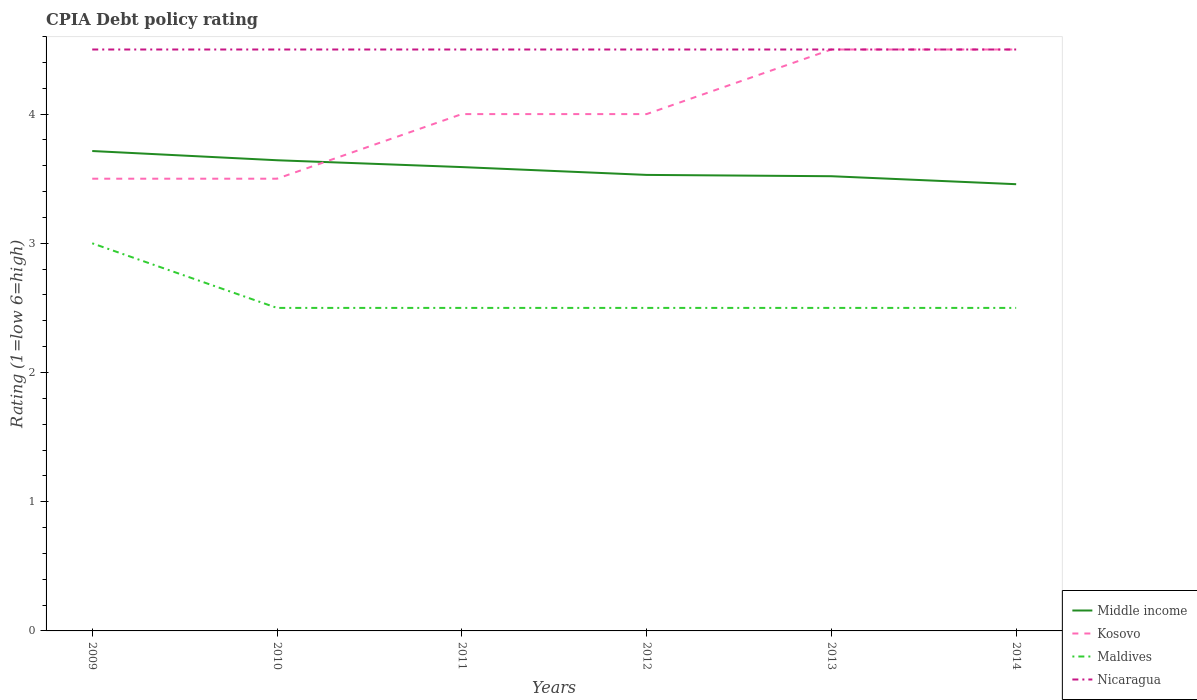How many different coloured lines are there?
Your response must be concise. 4. Does the line corresponding to Kosovo intersect with the line corresponding to Nicaragua?
Provide a short and direct response. Yes. Is the number of lines equal to the number of legend labels?
Ensure brevity in your answer.  Yes. Across all years, what is the maximum CPIA rating in Maldives?
Your answer should be compact. 2.5. What is the total CPIA rating in Maldives in the graph?
Provide a short and direct response. 0. Is the CPIA rating in Maldives strictly greater than the CPIA rating in Kosovo over the years?
Give a very brief answer. Yes. How many lines are there?
Your answer should be compact. 4. How many years are there in the graph?
Your answer should be compact. 6. What is the difference between two consecutive major ticks on the Y-axis?
Your response must be concise. 1. Are the values on the major ticks of Y-axis written in scientific E-notation?
Make the answer very short. No. Does the graph contain any zero values?
Provide a short and direct response. No. Does the graph contain grids?
Ensure brevity in your answer.  No. What is the title of the graph?
Keep it short and to the point. CPIA Debt policy rating. What is the label or title of the X-axis?
Offer a very short reply. Years. What is the label or title of the Y-axis?
Your answer should be compact. Rating (1=low 6=high). What is the Rating (1=low 6=high) of Middle income in 2009?
Offer a terse response. 3.71. What is the Rating (1=low 6=high) in Middle income in 2010?
Offer a very short reply. 3.64. What is the Rating (1=low 6=high) of Kosovo in 2010?
Keep it short and to the point. 3.5. What is the Rating (1=low 6=high) of Nicaragua in 2010?
Provide a succinct answer. 4.5. What is the Rating (1=low 6=high) of Middle income in 2011?
Provide a succinct answer. 3.59. What is the Rating (1=low 6=high) of Kosovo in 2011?
Your response must be concise. 4. What is the Rating (1=low 6=high) of Maldives in 2011?
Keep it short and to the point. 2.5. What is the Rating (1=low 6=high) of Nicaragua in 2011?
Offer a terse response. 4.5. What is the Rating (1=low 6=high) in Middle income in 2012?
Give a very brief answer. 3.53. What is the Rating (1=low 6=high) of Maldives in 2012?
Your response must be concise. 2.5. What is the Rating (1=low 6=high) in Nicaragua in 2012?
Provide a short and direct response. 4.5. What is the Rating (1=low 6=high) of Middle income in 2013?
Your response must be concise. 3.52. What is the Rating (1=low 6=high) in Kosovo in 2013?
Provide a succinct answer. 4.5. What is the Rating (1=low 6=high) in Nicaragua in 2013?
Provide a succinct answer. 4.5. What is the Rating (1=low 6=high) in Middle income in 2014?
Your answer should be compact. 3.46. What is the Rating (1=low 6=high) of Kosovo in 2014?
Your answer should be compact. 4.5. What is the Rating (1=low 6=high) in Nicaragua in 2014?
Make the answer very short. 4.5. Across all years, what is the maximum Rating (1=low 6=high) of Middle income?
Your response must be concise. 3.71. Across all years, what is the minimum Rating (1=low 6=high) in Middle income?
Give a very brief answer. 3.46. Across all years, what is the minimum Rating (1=low 6=high) of Maldives?
Offer a very short reply. 2.5. What is the total Rating (1=low 6=high) of Middle income in the graph?
Your answer should be very brief. 21.45. What is the total Rating (1=low 6=high) in Kosovo in the graph?
Your answer should be compact. 24. What is the difference between the Rating (1=low 6=high) of Middle income in 2009 and that in 2010?
Provide a short and direct response. 0.07. What is the difference between the Rating (1=low 6=high) of Kosovo in 2009 and that in 2010?
Make the answer very short. 0. What is the difference between the Rating (1=low 6=high) in Maldives in 2009 and that in 2010?
Offer a very short reply. 0.5. What is the difference between the Rating (1=low 6=high) of Middle income in 2009 and that in 2011?
Offer a terse response. 0.12. What is the difference between the Rating (1=low 6=high) in Nicaragua in 2009 and that in 2011?
Offer a terse response. 0. What is the difference between the Rating (1=low 6=high) in Middle income in 2009 and that in 2012?
Keep it short and to the point. 0.18. What is the difference between the Rating (1=low 6=high) in Middle income in 2009 and that in 2013?
Your answer should be compact. 0.2. What is the difference between the Rating (1=low 6=high) in Kosovo in 2009 and that in 2013?
Offer a terse response. -1. What is the difference between the Rating (1=low 6=high) in Maldives in 2009 and that in 2013?
Offer a very short reply. 0.5. What is the difference between the Rating (1=low 6=high) in Nicaragua in 2009 and that in 2013?
Make the answer very short. 0. What is the difference between the Rating (1=low 6=high) of Middle income in 2009 and that in 2014?
Ensure brevity in your answer.  0.26. What is the difference between the Rating (1=low 6=high) in Kosovo in 2009 and that in 2014?
Offer a terse response. -1. What is the difference between the Rating (1=low 6=high) in Middle income in 2010 and that in 2011?
Make the answer very short. 0.05. What is the difference between the Rating (1=low 6=high) of Kosovo in 2010 and that in 2011?
Your answer should be very brief. -0.5. What is the difference between the Rating (1=low 6=high) in Maldives in 2010 and that in 2011?
Give a very brief answer. 0. What is the difference between the Rating (1=low 6=high) of Middle income in 2010 and that in 2012?
Your response must be concise. 0.11. What is the difference between the Rating (1=low 6=high) in Nicaragua in 2010 and that in 2012?
Keep it short and to the point. 0. What is the difference between the Rating (1=low 6=high) of Middle income in 2010 and that in 2013?
Offer a terse response. 0.12. What is the difference between the Rating (1=low 6=high) in Kosovo in 2010 and that in 2013?
Ensure brevity in your answer.  -1. What is the difference between the Rating (1=low 6=high) in Maldives in 2010 and that in 2013?
Make the answer very short. 0. What is the difference between the Rating (1=low 6=high) of Middle income in 2010 and that in 2014?
Your response must be concise. 0.19. What is the difference between the Rating (1=low 6=high) in Middle income in 2011 and that in 2012?
Provide a succinct answer. 0.06. What is the difference between the Rating (1=low 6=high) of Kosovo in 2011 and that in 2012?
Your response must be concise. 0. What is the difference between the Rating (1=low 6=high) in Middle income in 2011 and that in 2013?
Keep it short and to the point. 0.07. What is the difference between the Rating (1=low 6=high) of Kosovo in 2011 and that in 2013?
Ensure brevity in your answer.  -0.5. What is the difference between the Rating (1=low 6=high) in Middle income in 2011 and that in 2014?
Provide a succinct answer. 0.13. What is the difference between the Rating (1=low 6=high) in Nicaragua in 2011 and that in 2014?
Your response must be concise. 0. What is the difference between the Rating (1=low 6=high) in Middle income in 2012 and that in 2013?
Your answer should be very brief. 0.01. What is the difference between the Rating (1=low 6=high) of Kosovo in 2012 and that in 2013?
Your answer should be compact. -0.5. What is the difference between the Rating (1=low 6=high) of Middle income in 2012 and that in 2014?
Provide a short and direct response. 0.07. What is the difference between the Rating (1=low 6=high) in Middle income in 2013 and that in 2014?
Ensure brevity in your answer.  0.06. What is the difference between the Rating (1=low 6=high) in Maldives in 2013 and that in 2014?
Ensure brevity in your answer.  0. What is the difference between the Rating (1=low 6=high) of Middle income in 2009 and the Rating (1=low 6=high) of Kosovo in 2010?
Keep it short and to the point. 0.21. What is the difference between the Rating (1=low 6=high) of Middle income in 2009 and the Rating (1=low 6=high) of Maldives in 2010?
Ensure brevity in your answer.  1.21. What is the difference between the Rating (1=low 6=high) of Middle income in 2009 and the Rating (1=low 6=high) of Nicaragua in 2010?
Offer a very short reply. -0.79. What is the difference between the Rating (1=low 6=high) of Kosovo in 2009 and the Rating (1=low 6=high) of Maldives in 2010?
Provide a short and direct response. 1. What is the difference between the Rating (1=low 6=high) in Maldives in 2009 and the Rating (1=low 6=high) in Nicaragua in 2010?
Your answer should be compact. -1.5. What is the difference between the Rating (1=low 6=high) in Middle income in 2009 and the Rating (1=low 6=high) in Kosovo in 2011?
Offer a very short reply. -0.29. What is the difference between the Rating (1=low 6=high) in Middle income in 2009 and the Rating (1=low 6=high) in Maldives in 2011?
Give a very brief answer. 1.21. What is the difference between the Rating (1=low 6=high) of Middle income in 2009 and the Rating (1=low 6=high) of Nicaragua in 2011?
Keep it short and to the point. -0.79. What is the difference between the Rating (1=low 6=high) in Kosovo in 2009 and the Rating (1=low 6=high) in Maldives in 2011?
Ensure brevity in your answer.  1. What is the difference between the Rating (1=low 6=high) of Maldives in 2009 and the Rating (1=low 6=high) of Nicaragua in 2011?
Keep it short and to the point. -1.5. What is the difference between the Rating (1=low 6=high) of Middle income in 2009 and the Rating (1=low 6=high) of Kosovo in 2012?
Offer a terse response. -0.29. What is the difference between the Rating (1=low 6=high) in Middle income in 2009 and the Rating (1=low 6=high) in Maldives in 2012?
Ensure brevity in your answer.  1.21. What is the difference between the Rating (1=low 6=high) of Middle income in 2009 and the Rating (1=low 6=high) of Nicaragua in 2012?
Keep it short and to the point. -0.79. What is the difference between the Rating (1=low 6=high) in Kosovo in 2009 and the Rating (1=low 6=high) in Nicaragua in 2012?
Offer a very short reply. -1. What is the difference between the Rating (1=low 6=high) of Maldives in 2009 and the Rating (1=low 6=high) of Nicaragua in 2012?
Give a very brief answer. -1.5. What is the difference between the Rating (1=low 6=high) in Middle income in 2009 and the Rating (1=low 6=high) in Kosovo in 2013?
Keep it short and to the point. -0.79. What is the difference between the Rating (1=low 6=high) in Middle income in 2009 and the Rating (1=low 6=high) in Maldives in 2013?
Your answer should be compact. 1.21. What is the difference between the Rating (1=low 6=high) in Middle income in 2009 and the Rating (1=low 6=high) in Nicaragua in 2013?
Your answer should be very brief. -0.79. What is the difference between the Rating (1=low 6=high) of Kosovo in 2009 and the Rating (1=low 6=high) of Maldives in 2013?
Provide a succinct answer. 1. What is the difference between the Rating (1=low 6=high) in Kosovo in 2009 and the Rating (1=low 6=high) in Nicaragua in 2013?
Ensure brevity in your answer.  -1. What is the difference between the Rating (1=low 6=high) in Maldives in 2009 and the Rating (1=low 6=high) in Nicaragua in 2013?
Give a very brief answer. -1.5. What is the difference between the Rating (1=low 6=high) in Middle income in 2009 and the Rating (1=low 6=high) in Kosovo in 2014?
Your answer should be compact. -0.79. What is the difference between the Rating (1=low 6=high) in Middle income in 2009 and the Rating (1=low 6=high) in Maldives in 2014?
Provide a short and direct response. 1.21. What is the difference between the Rating (1=low 6=high) of Middle income in 2009 and the Rating (1=low 6=high) of Nicaragua in 2014?
Give a very brief answer. -0.79. What is the difference between the Rating (1=low 6=high) in Kosovo in 2009 and the Rating (1=low 6=high) in Maldives in 2014?
Your answer should be compact. 1. What is the difference between the Rating (1=low 6=high) in Kosovo in 2009 and the Rating (1=low 6=high) in Nicaragua in 2014?
Give a very brief answer. -1. What is the difference between the Rating (1=low 6=high) of Middle income in 2010 and the Rating (1=low 6=high) of Kosovo in 2011?
Ensure brevity in your answer.  -0.36. What is the difference between the Rating (1=low 6=high) in Middle income in 2010 and the Rating (1=low 6=high) in Maldives in 2011?
Ensure brevity in your answer.  1.14. What is the difference between the Rating (1=low 6=high) of Middle income in 2010 and the Rating (1=low 6=high) of Nicaragua in 2011?
Keep it short and to the point. -0.86. What is the difference between the Rating (1=low 6=high) of Kosovo in 2010 and the Rating (1=low 6=high) of Maldives in 2011?
Offer a terse response. 1. What is the difference between the Rating (1=low 6=high) of Kosovo in 2010 and the Rating (1=low 6=high) of Nicaragua in 2011?
Give a very brief answer. -1. What is the difference between the Rating (1=low 6=high) in Maldives in 2010 and the Rating (1=low 6=high) in Nicaragua in 2011?
Give a very brief answer. -2. What is the difference between the Rating (1=low 6=high) in Middle income in 2010 and the Rating (1=low 6=high) in Kosovo in 2012?
Your answer should be compact. -0.36. What is the difference between the Rating (1=low 6=high) of Middle income in 2010 and the Rating (1=low 6=high) of Maldives in 2012?
Provide a succinct answer. 1.14. What is the difference between the Rating (1=low 6=high) in Middle income in 2010 and the Rating (1=low 6=high) in Nicaragua in 2012?
Your answer should be compact. -0.86. What is the difference between the Rating (1=low 6=high) of Kosovo in 2010 and the Rating (1=low 6=high) of Maldives in 2012?
Provide a succinct answer. 1. What is the difference between the Rating (1=low 6=high) in Kosovo in 2010 and the Rating (1=low 6=high) in Nicaragua in 2012?
Your response must be concise. -1. What is the difference between the Rating (1=low 6=high) of Middle income in 2010 and the Rating (1=low 6=high) of Kosovo in 2013?
Offer a very short reply. -0.86. What is the difference between the Rating (1=low 6=high) in Middle income in 2010 and the Rating (1=low 6=high) in Maldives in 2013?
Ensure brevity in your answer.  1.14. What is the difference between the Rating (1=low 6=high) in Middle income in 2010 and the Rating (1=low 6=high) in Nicaragua in 2013?
Ensure brevity in your answer.  -0.86. What is the difference between the Rating (1=low 6=high) of Kosovo in 2010 and the Rating (1=low 6=high) of Maldives in 2013?
Ensure brevity in your answer.  1. What is the difference between the Rating (1=low 6=high) in Kosovo in 2010 and the Rating (1=low 6=high) in Nicaragua in 2013?
Offer a terse response. -1. What is the difference between the Rating (1=low 6=high) of Middle income in 2010 and the Rating (1=low 6=high) of Kosovo in 2014?
Offer a very short reply. -0.86. What is the difference between the Rating (1=low 6=high) of Middle income in 2010 and the Rating (1=low 6=high) of Nicaragua in 2014?
Keep it short and to the point. -0.86. What is the difference between the Rating (1=low 6=high) in Maldives in 2010 and the Rating (1=low 6=high) in Nicaragua in 2014?
Your answer should be compact. -2. What is the difference between the Rating (1=low 6=high) of Middle income in 2011 and the Rating (1=low 6=high) of Kosovo in 2012?
Provide a succinct answer. -0.41. What is the difference between the Rating (1=low 6=high) in Middle income in 2011 and the Rating (1=low 6=high) in Maldives in 2012?
Ensure brevity in your answer.  1.09. What is the difference between the Rating (1=low 6=high) of Middle income in 2011 and the Rating (1=low 6=high) of Nicaragua in 2012?
Provide a succinct answer. -0.91. What is the difference between the Rating (1=low 6=high) of Kosovo in 2011 and the Rating (1=low 6=high) of Maldives in 2012?
Provide a succinct answer. 1.5. What is the difference between the Rating (1=low 6=high) of Kosovo in 2011 and the Rating (1=low 6=high) of Nicaragua in 2012?
Give a very brief answer. -0.5. What is the difference between the Rating (1=low 6=high) in Middle income in 2011 and the Rating (1=low 6=high) in Kosovo in 2013?
Your answer should be very brief. -0.91. What is the difference between the Rating (1=low 6=high) in Middle income in 2011 and the Rating (1=low 6=high) in Maldives in 2013?
Your answer should be compact. 1.09. What is the difference between the Rating (1=low 6=high) in Middle income in 2011 and the Rating (1=low 6=high) in Nicaragua in 2013?
Keep it short and to the point. -0.91. What is the difference between the Rating (1=low 6=high) of Kosovo in 2011 and the Rating (1=low 6=high) of Maldives in 2013?
Your answer should be compact. 1.5. What is the difference between the Rating (1=low 6=high) of Kosovo in 2011 and the Rating (1=low 6=high) of Nicaragua in 2013?
Make the answer very short. -0.5. What is the difference between the Rating (1=low 6=high) in Middle income in 2011 and the Rating (1=low 6=high) in Kosovo in 2014?
Offer a very short reply. -0.91. What is the difference between the Rating (1=low 6=high) in Middle income in 2011 and the Rating (1=low 6=high) in Maldives in 2014?
Provide a succinct answer. 1.09. What is the difference between the Rating (1=low 6=high) of Middle income in 2011 and the Rating (1=low 6=high) of Nicaragua in 2014?
Ensure brevity in your answer.  -0.91. What is the difference between the Rating (1=low 6=high) in Middle income in 2012 and the Rating (1=low 6=high) in Kosovo in 2013?
Offer a terse response. -0.97. What is the difference between the Rating (1=low 6=high) of Middle income in 2012 and the Rating (1=low 6=high) of Maldives in 2013?
Your answer should be compact. 1.03. What is the difference between the Rating (1=low 6=high) in Middle income in 2012 and the Rating (1=low 6=high) in Nicaragua in 2013?
Your answer should be compact. -0.97. What is the difference between the Rating (1=low 6=high) of Kosovo in 2012 and the Rating (1=low 6=high) of Maldives in 2013?
Offer a very short reply. 1.5. What is the difference between the Rating (1=low 6=high) in Kosovo in 2012 and the Rating (1=low 6=high) in Nicaragua in 2013?
Provide a succinct answer. -0.5. What is the difference between the Rating (1=low 6=high) of Maldives in 2012 and the Rating (1=low 6=high) of Nicaragua in 2013?
Your response must be concise. -2. What is the difference between the Rating (1=low 6=high) of Middle income in 2012 and the Rating (1=low 6=high) of Kosovo in 2014?
Offer a terse response. -0.97. What is the difference between the Rating (1=low 6=high) in Middle income in 2012 and the Rating (1=low 6=high) in Maldives in 2014?
Your answer should be compact. 1.03. What is the difference between the Rating (1=low 6=high) of Middle income in 2012 and the Rating (1=low 6=high) of Nicaragua in 2014?
Ensure brevity in your answer.  -0.97. What is the difference between the Rating (1=low 6=high) in Kosovo in 2012 and the Rating (1=low 6=high) in Maldives in 2014?
Make the answer very short. 1.5. What is the difference between the Rating (1=low 6=high) of Middle income in 2013 and the Rating (1=low 6=high) of Kosovo in 2014?
Keep it short and to the point. -0.98. What is the difference between the Rating (1=low 6=high) in Middle income in 2013 and the Rating (1=low 6=high) in Maldives in 2014?
Keep it short and to the point. 1.02. What is the difference between the Rating (1=low 6=high) of Middle income in 2013 and the Rating (1=low 6=high) of Nicaragua in 2014?
Offer a terse response. -0.98. What is the difference between the Rating (1=low 6=high) in Kosovo in 2013 and the Rating (1=low 6=high) in Maldives in 2014?
Ensure brevity in your answer.  2. What is the difference between the Rating (1=low 6=high) in Maldives in 2013 and the Rating (1=low 6=high) in Nicaragua in 2014?
Ensure brevity in your answer.  -2. What is the average Rating (1=low 6=high) of Middle income per year?
Offer a very short reply. 3.58. What is the average Rating (1=low 6=high) of Maldives per year?
Provide a short and direct response. 2.58. What is the average Rating (1=low 6=high) of Nicaragua per year?
Your response must be concise. 4.5. In the year 2009, what is the difference between the Rating (1=low 6=high) in Middle income and Rating (1=low 6=high) in Kosovo?
Make the answer very short. 0.21. In the year 2009, what is the difference between the Rating (1=low 6=high) of Middle income and Rating (1=low 6=high) of Nicaragua?
Provide a succinct answer. -0.79. In the year 2009, what is the difference between the Rating (1=low 6=high) in Maldives and Rating (1=low 6=high) in Nicaragua?
Give a very brief answer. -1.5. In the year 2010, what is the difference between the Rating (1=low 6=high) in Middle income and Rating (1=low 6=high) in Kosovo?
Give a very brief answer. 0.14. In the year 2010, what is the difference between the Rating (1=low 6=high) in Middle income and Rating (1=low 6=high) in Maldives?
Keep it short and to the point. 1.14. In the year 2010, what is the difference between the Rating (1=low 6=high) in Middle income and Rating (1=low 6=high) in Nicaragua?
Your answer should be compact. -0.86. In the year 2010, what is the difference between the Rating (1=low 6=high) in Kosovo and Rating (1=low 6=high) in Nicaragua?
Your answer should be very brief. -1. In the year 2011, what is the difference between the Rating (1=low 6=high) of Middle income and Rating (1=low 6=high) of Kosovo?
Give a very brief answer. -0.41. In the year 2011, what is the difference between the Rating (1=low 6=high) in Middle income and Rating (1=low 6=high) in Maldives?
Ensure brevity in your answer.  1.09. In the year 2011, what is the difference between the Rating (1=low 6=high) of Middle income and Rating (1=low 6=high) of Nicaragua?
Your answer should be compact. -0.91. In the year 2011, what is the difference between the Rating (1=low 6=high) of Kosovo and Rating (1=low 6=high) of Maldives?
Keep it short and to the point. 1.5. In the year 2011, what is the difference between the Rating (1=low 6=high) of Kosovo and Rating (1=low 6=high) of Nicaragua?
Ensure brevity in your answer.  -0.5. In the year 2012, what is the difference between the Rating (1=low 6=high) in Middle income and Rating (1=low 6=high) in Kosovo?
Offer a terse response. -0.47. In the year 2012, what is the difference between the Rating (1=low 6=high) of Middle income and Rating (1=low 6=high) of Maldives?
Your answer should be very brief. 1.03. In the year 2012, what is the difference between the Rating (1=low 6=high) in Middle income and Rating (1=low 6=high) in Nicaragua?
Make the answer very short. -0.97. In the year 2012, what is the difference between the Rating (1=low 6=high) of Kosovo and Rating (1=low 6=high) of Maldives?
Make the answer very short. 1.5. In the year 2012, what is the difference between the Rating (1=low 6=high) of Kosovo and Rating (1=low 6=high) of Nicaragua?
Provide a succinct answer. -0.5. In the year 2012, what is the difference between the Rating (1=low 6=high) of Maldives and Rating (1=low 6=high) of Nicaragua?
Offer a terse response. -2. In the year 2013, what is the difference between the Rating (1=low 6=high) of Middle income and Rating (1=low 6=high) of Kosovo?
Provide a short and direct response. -0.98. In the year 2013, what is the difference between the Rating (1=low 6=high) of Middle income and Rating (1=low 6=high) of Maldives?
Make the answer very short. 1.02. In the year 2013, what is the difference between the Rating (1=low 6=high) in Middle income and Rating (1=low 6=high) in Nicaragua?
Offer a terse response. -0.98. In the year 2014, what is the difference between the Rating (1=low 6=high) in Middle income and Rating (1=low 6=high) in Kosovo?
Your answer should be compact. -1.04. In the year 2014, what is the difference between the Rating (1=low 6=high) of Middle income and Rating (1=low 6=high) of Maldives?
Provide a succinct answer. 0.96. In the year 2014, what is the difference between the Rating (1=low 6=high) of Middle income and Rating (1=low 6=high) of Nicaragua?
Give a very brief answer. -1.04. In the year 2014, what is the difference between the Rating (1=low 6=high) in Kosovo and Rating (1=low 6=high) in Nicaragua?
Offer a very short reply. 0. What is the ratio of the Rating (1=low 6=high) of Middle income in 2009 to that in 2010?
Your response must be concise. 1.02. What is the ratio of the Rating (1=low 6=high) of Kosovo in 2009 to that in 2010?
Keep it short and to the point. 1. What is the ratio of the Rating (1=low 6=high) in Maldives in 2009 to that in 2010?
Your response must be concise. 1.2. What is the ratio of the Rating (1=low 6=high) of Middle income in 2009 to that in 2011?
Your response must be concise. 1.03. What is the ratio of the Rating (1=low 6=high) in Maldives in 2009 to that in 2011?
Provide a succinct answer. 1.2. What is the ratio of the Rating (1=low 6=high) of Nicaragua in 2009 to that in 2011?
Your answer should be very brief. 1. What is the ratio of the Rating (1=low 6=high) in Middle income in 2009 to that in 2012?
Offer a terse response. 1.05. What is the ratio of the Rating (1=low 6=high) of Kosovo in 2009 to that in 2012?
Offer a terse response. 0.88. What is the ratio of the Rating (1=low 6=high) in Maldives in 2009 to that in 2012?
Ensure brevity in your answer.  1.2. What is the ratio of the Rating (1=low 6=high) of Nicaragua in 2009 to that in 2012?
Your response must be concise. 1. What is the ratio of the Rating (1=low 6=high) in Middle income in 2009 to that in 2013?
Your answer should be very brief. 1.06. What is the ratio of the Rating (1=low 6=high) of Maldives in 2009 to that in 2013?
Offer a very short reply. 1.2. What is the ratio of the Rating (1=low 6=high) of Nicaragua in 2009 to that in 2013?
Give a very brief answer. 1. What is the ratio of the Rating (1=low 6=high) in Middle income in 2009 to that in 2014?
Provide a short and direct response. 1.07. What is the ratio of the Rating (1=low 6=high) of Nicaragua in 2009 to that in 2014?
Provide a short and direct response. 1. What is the ratio of the Rating (1=low 6=high) in Middle income in 2010 to that in 2011?
Provide a succinct answer. 1.01. What is the ratio of the Rating (1=low 6=high) in Maldives in 2010 to that in 2011?
Make the answer very short. 1. What is the ratio of the Rating (1=low 6=high) of Nicaragua in 2010 to that in 2011?
Ensure brevity in your answer.  1. What is the ratio of the Rating (1=low 6=high) in Middle income in 2010 to that in 2012?
Offer a very short reply. 1.03. What is the ratio of the Rating (1=low 6=high) of Kosovo in 2010 to that in 2012?
Offer a very short reply. 0.88. What is the ratio of the Rating (1=low 6=high) of Maldives in 2010 to that in 2012?
Provide a succinct answer. 1. What is the ratio of the Rating (1=low 6=high) in Middle income in 2010 to that in 2013?
Your answer should be compact. 1.04. What is the ratio of the Rating (1=low 6=high) of Maldives in 2010 to that in 2013?
Keep it short and to the point. 1. What is the ratio of the Rating (1=low 6=high) in Nicaragua in 2010 to that in 2013?
Ensure brevity in your answer.  1. What is the ratio of the Rating (1=low 6=high) of Middle income in 2010 to that in 2014?
Your answer should be very brief. 1.05. What is the ratio of the Rating (1=low 6=high) in Middle income in 2011 to that in 2012?
Provide a succinct answer. 1.02. What is the ratio of the Rating (1=low 6=high) in Kosovo in 2011 to that in 2012?
Make the answer very short. 1. What is the ratio of the Rating (1=low 6=high) of Middle income in 2011 to that in 2013?
Provide a short and direct response. 1.02. What is the ratio of the Rating (1=low 6=high) in Kosovo in 2011 to that in 2013?
Make the answer very short. 0.89. What is the ratio of the Rating (1=low 6=high) in Maldives in 2011 to that in 2013?
Your answer should be very brief. 1. What is the ratio of the Rating (1=low 6=high) of Nicaragua in 2011 to that in 2013?
Your answer should be very brief. 1. What is the ratio of the Rating (1=low 6=high) of Middle income in 2011 to that in 2014?
Offer a terse response. 1.04. What is the ratio of the Rating (1=low 6=high) of Kosovo in 2011 to that in 2014?
Give a very brief answer. 0.89. What is the ratio of the Rating (1=low 6=high) of Nicaragua in 2011 to that in 2014?
Make the answer very short. 1. What is the ratio of the Rating (1=low 6=high) in Middle income in 2012 to that in 2013?
Give a very brief answer. 1. What is the ratio of the Rating (1=low 6=high) of Kosovo in 2012 to that in 2013?
Offer a very short reply. 0.89. What is the ratio of the Rating (1=low 6=high) in Middle income in 2012 to that in 2014?
Give a very brief answer. 1.02. What is the ratio of the Rating (1=low 6=high) in Maldives in 2012 to that in 2014?
Your response must be concise. 1. What is the ratio of the Rating (1=low 6=high) in Nicaragua in 2012 to that in 2014?
Offer a terse response. 1. What is the ratio of the Rating (1=low 6=high) in Middle income in 2013 to that in 2014?
Provide a succinct answer. 1.02. What is the ratio of the Rating (1=low 6=high) of Kosovo in 2013 to that in 2014?
Provide a short and direct response. 1. What is the difference between the highest and the second highest Rating (1=low 6=high) in Middle income?
Provide a short and direct response. 0.07. What is the difference between the highest and the lowest Rating (1=low 6=high) of Middle income?
Provide a short and direct response. 0.26. What is the difference between the highest and the lowest Rating (1=low 6=high) in Kosovo?
Make the answer very short. 1. What is the difference between the highest and the lowest Rating (1=low 6=high) of Maldives?
Provide a short and direct response. 0.5. What is the difference between the highest and the lowest Rating (1=low 6=high) in Nicaragua?
Offer a very short reply. 0. 